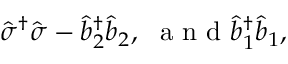<formula> <loc_0><loc_0><loc_500><loc_500>\hat { \sigma } ^ { \dagger } \hat { \sigma } - \hat { b } _ { 2 } ^ { \dagger } \hat { b } _ { 2 } , \ a n d \hat { b } _ { 1 } ^ { \dagger } \hat { b } _ { 1 } ,</formula> 